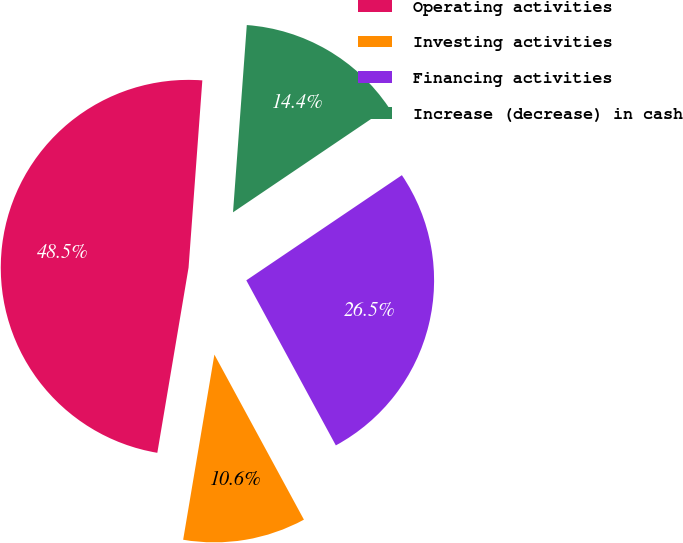Convert chart to OTSL. <chart><loc_0><loc_0><loc_500><loc_500><pie_chart><fcel>Operating activities<fcel>Investing activities<fcel>Financing activities<fcel>Increase (decrease) in cash<nl><fcel>48.51%<fcel>10.57%<fcel>26.55%<fcel>14.37%<nl></chart> 